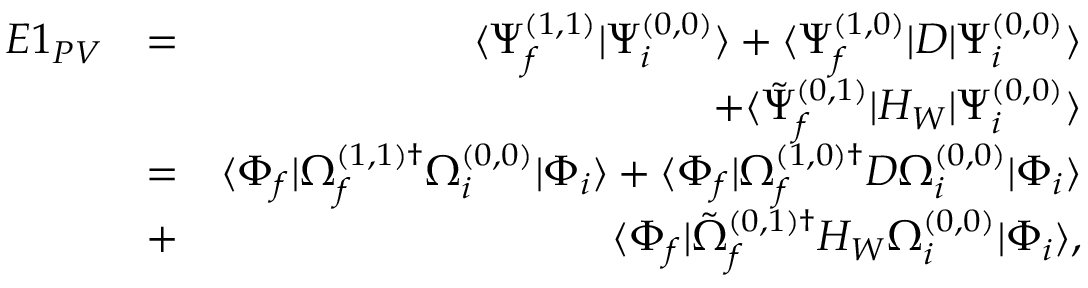<formula> <loc_0><loc_0><loc_500><loc_500>\begin{array} { r l r } { E 1 _ { P V } } & { = } & { \langle \Psi _ { f } ^ { ( 1 , 1 ) } | \Psi _ { i } ^ { ( 0 , 0 ) } \rangle + \langle \Psi _ { f } ^ { ( 1 , 0 ) } | D | \Psi _ { i } ^ { ( 0 , 0 ) } \rangle } \\ & { + \langle \tilde { \Psi } _ { f } ^ { ( 0 , 1 ) } | H _ { W } | \Psi _ { i } ^ { ( 0 , 0 ) } \rangle } \\ & { = } & { \langle \Phi _ { f } | \Omega _ { f } ^ { ( 1 , 1 ) \dagger } \Omega _ { i } ^ { ( 0 , 0 ) } | \Phi _ { i } \rangle + \langle \Phi _ { f } | \Omega _ { f } ^ { ( 1 , 0 ) \dagger } D \Omega _ { i } ^ { ( 0 , 0 ) } | \Phi _ { i } \rangle } \\ & { + } & { \langle \Phi _ { f } | \tilde { \Omega } _ { f } ^ { ( 0 , 1 ) \dagger } H _ { W } \Omega _ { i } ^ { ( 0 , 0 ) } | \Phi _ { i } \rangle , } \end{array}</formula> 